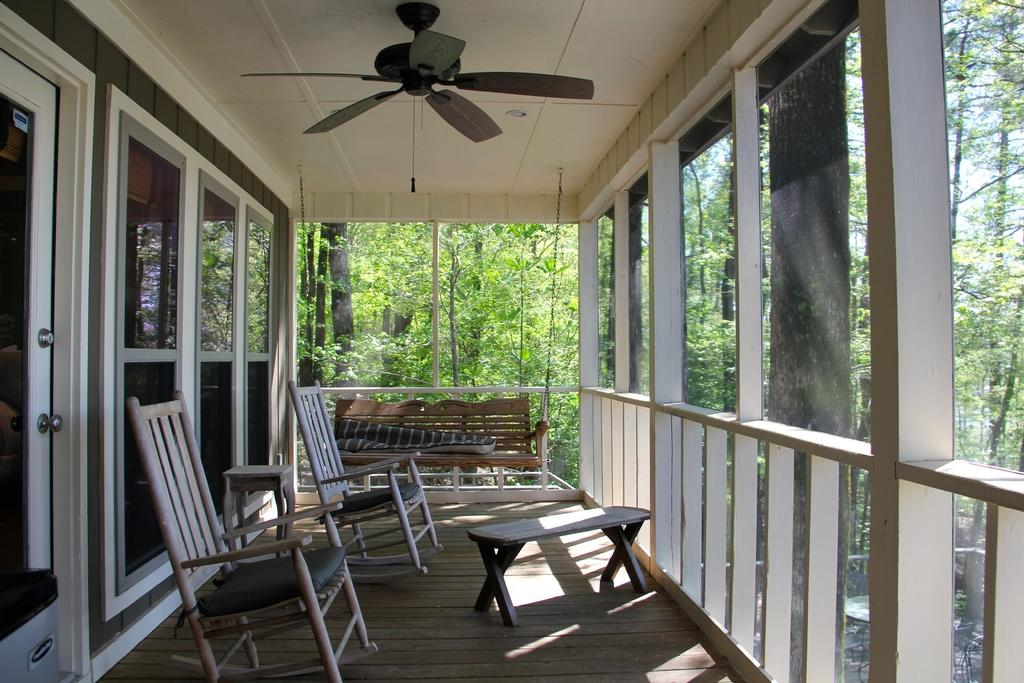What type of furniture is located at the bottom of the image? There are chairs and tables at the bottom of the image. What material is used for the walls on the left side of the image? The walls on the left side of the image are made of glass. What feature is present on the left side of the image that allows access? There is a glass door on the left side of the image. What can be seen at the top of the image? There is a ceiling fan at the top of the image. Can you hear the sign laughing in the image? There is no sign present in the image, and signs do not have the ability to laugh. 